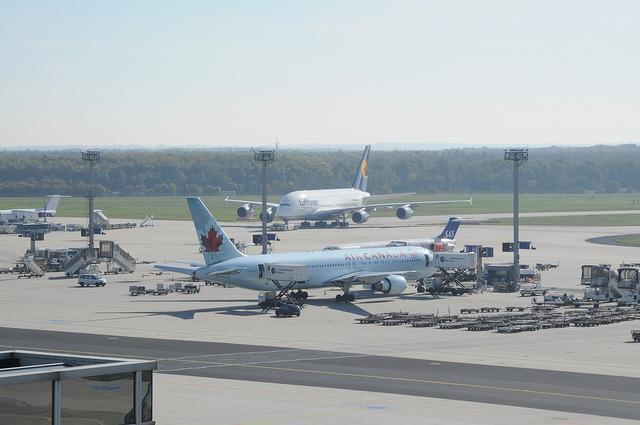What continent is the plane in the foreground from?
Pick the correct solution from the four options below to address the question.
Options: Antarctica, asia, north america, south america. North america. 